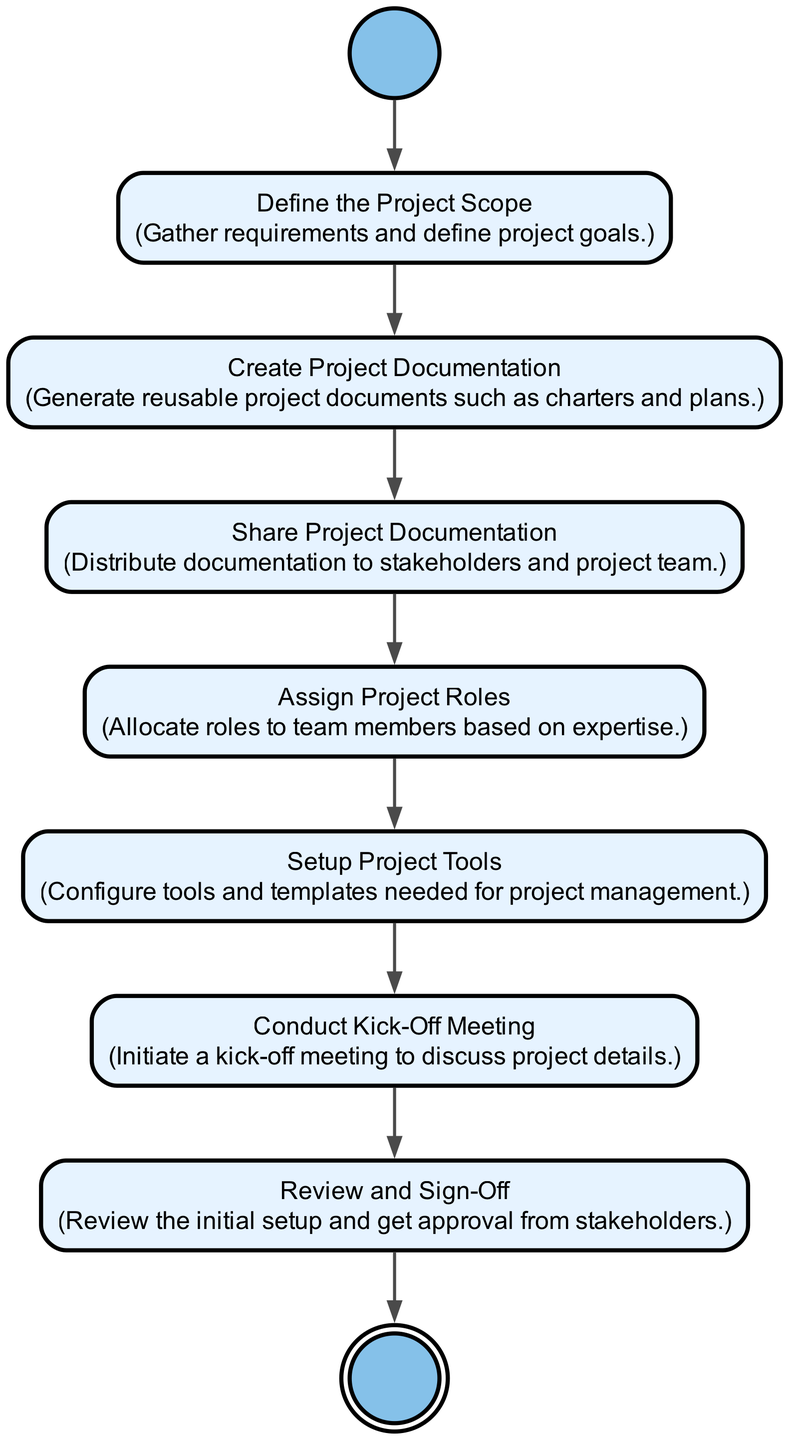What is the first step in the onboarding process? The first step, as indicated in the diagram, is labeled "Start of the onboarding process," which transitions to the next activity.
Answer: Define Project Scope How many activities are there in the workflow? By counting the activities listed in the diagram, there are a total of six activities, excluding the start and end nodes.
Answer: 6 What is the action associated with the "Conduct Kick-Off Meeting" activity? The description for "Conduct Kick-Off Meeting" in the diagram states that it involves initiating a kick-off meeting to discuss project details.
Answer: Initiate a kick-off meeting to discuss project details Which activity comes after "Setup Project Tools"? The transition from "Setup Project Tools" in the diagram leads directly to "Conduct Kick-Off Meeting," making it the next activity in the process.
Answer: Conduct Kick-Off Meeting What type of diagram is being represented here? As per the content and structure focusing on activities and their transitions, this is identified as an Activity Diagram.
Answer: Activity Diagram Why is sharing project documentation a critical step? Sharing project documentation is crucial as it ensures that stakeholders and the project team are informed and aligned, which is essential for project success.
Answer: Ensures stakeholders and team are informed What is the final action before reaching the end of the process? The last activity before concluding the diagram is "Review and Sign-Off", which necessitates obtaining approval from stakeholders, leading to the end.
Answer: Review and Sign-Off How many final nodes are in this diagram? This diagram contains only one final node, which signifies the completion of the workflow.
Answer: 1 What happens after defining the project scope? After defining the project scope, the next step, as per the diagram, is to "Create Project Documentation."
Answer: Create Project Documentation 